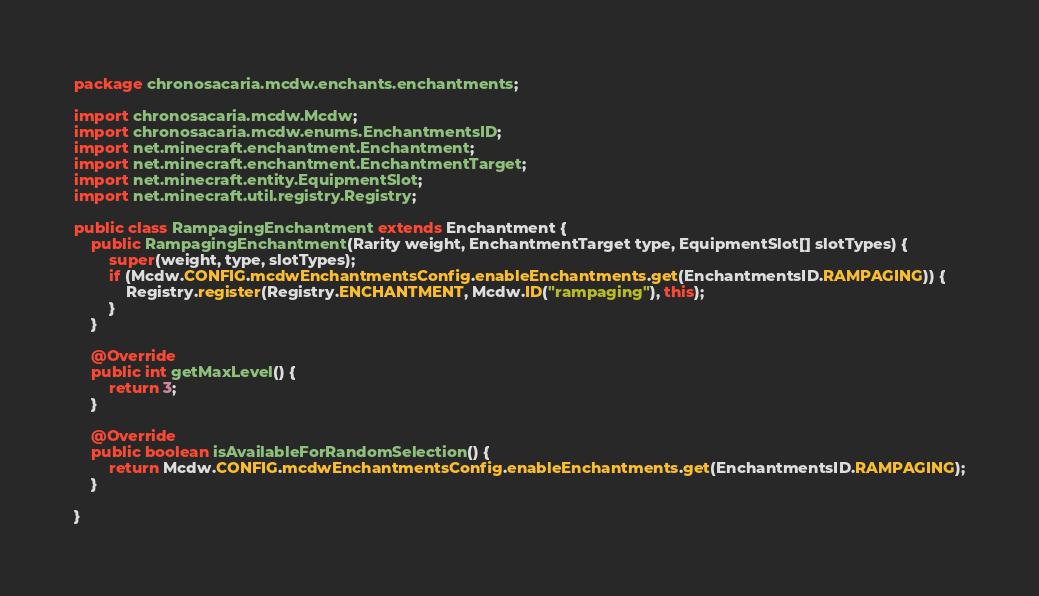Convert code to text. <code><loc_0><loc_0><loc_500><loc_500><_Java_>package chronosacaria.mcdw.enchants.enchantments;

import chronosacaria.mcdw.Mcdw;
import chronosacaria.mcdw.enums.EnchantmentsID;
import net.minecraft.enchantment.Enchantment;
import net.minecraft.enchantment.EnchantmentTarget;
import net.minecraft.entity.EquipmentSlot;
import net.minecraft.util.registry.Registry;

public class RampagingEnchantment extends Enchantment {
    public RampagingEnchantment(Rarity weight, EnchantmentTarget type, EquipmentSlot[] slotTypes) {
        super(weight, type, slotTypes);
        if (Mcdw.CONFIG.mcdwEnchantmentsConfig.enableEnchantments.get(EnchantmentsID.RAMPAGING)) {
            Registry.register(Registry.ENCHANTMENT, Mcdw.ID("rampaging"), this);
        }
    }

    @Override
    public int getMaxLevel() {
        return 3;
    }

    @Override
    public boolean isAvailableForRandomSelection() {
        return Mcdw.CONFIG.mcdwEnchantmentsConfig.enableEnchantments.get(EnchantmentsID.RAMPAGING);
    }

}
</code> 